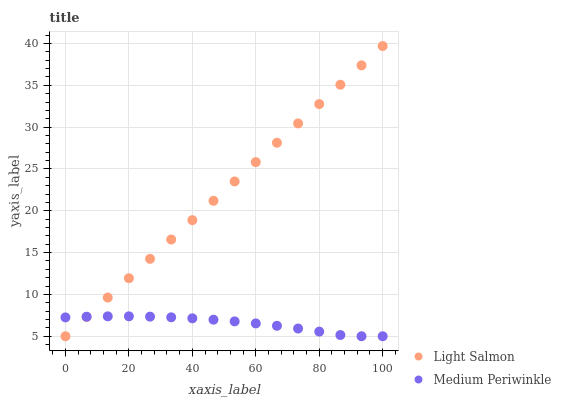Does Medium Periwinkle have the minimum area under the curve?
Answer yes or no. Yes. Does Light Salmon have the maximum area under the curve?
Answer yes or no. Yes. Does Medium Periwinkle have the maximum area under the curve?
Answer yes or no. No. Is Light Salmon the smoothest?
Answer yes or no. Yes. Is Medium Periwinkle the roughest?
Answer yes or no. Yes. Is Medium Periwinkle the smoothest?
Answer yes or no. No. Does Light Salmon have the lowest value?
Answer yes or no. Yes. Does Light Salmon have the highest value?
Answer yes or no. Yes. Does Medium Periwinkle have the highest value?
Answer yes or no. No. Does Medium Periwinkle intersect Light Salmon?
Answer yes or no. Yes. Is Medium Periwinkle less than Light Salmon?
Answer yes or no. No. Is Medium Periwinkle greater than Light Salmon?
Answer yes or no. No. 